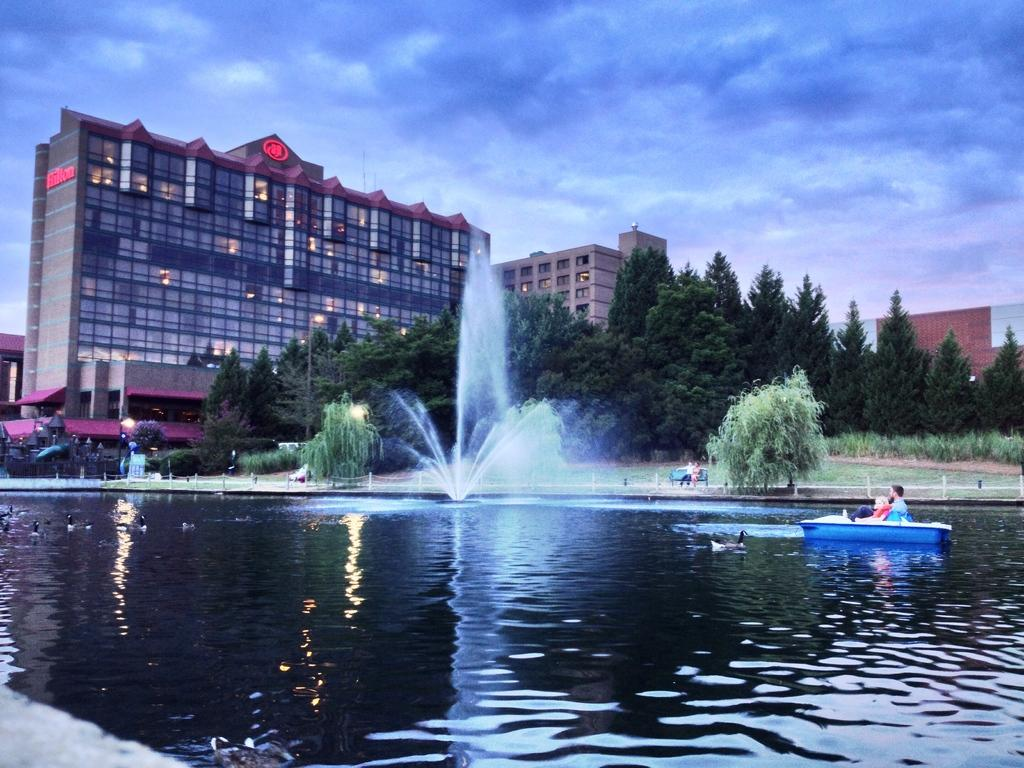What is the primary element in the image? There is water in the image. What other living organisms can be seen in the image? There are plants, ducks, and a person sitting in the boat in the image. What type of structure is present in the image? There is a building in the image. What can be used for sitting or resting in the image? There is a bench in the image. What is visible in the sky in the image? The sky is visible in the image, and there are clouds in the sky. What type of church can be seen in the image? There is no church present in the image. What angle is the street shown from in the image? There is no street present in the image. 